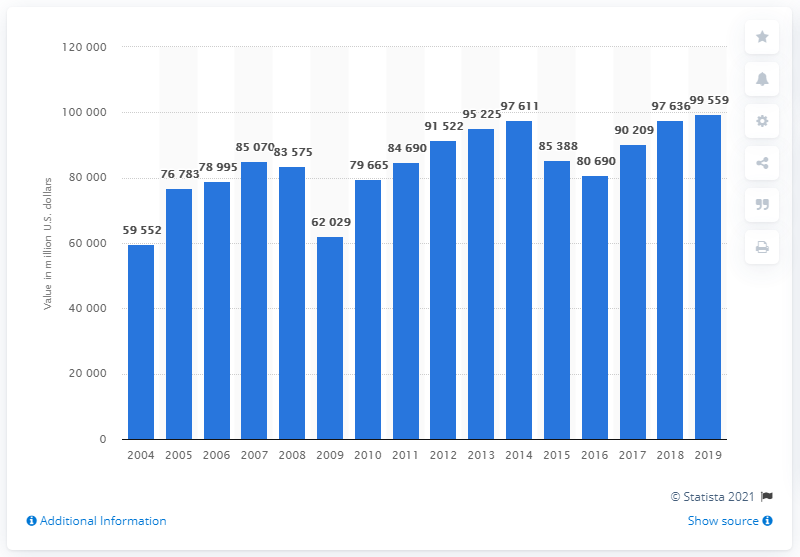Indicate a few pertinent items in this graphic. In the United States in 2019, the shipment value of plastic resins was approximately $995,599. 